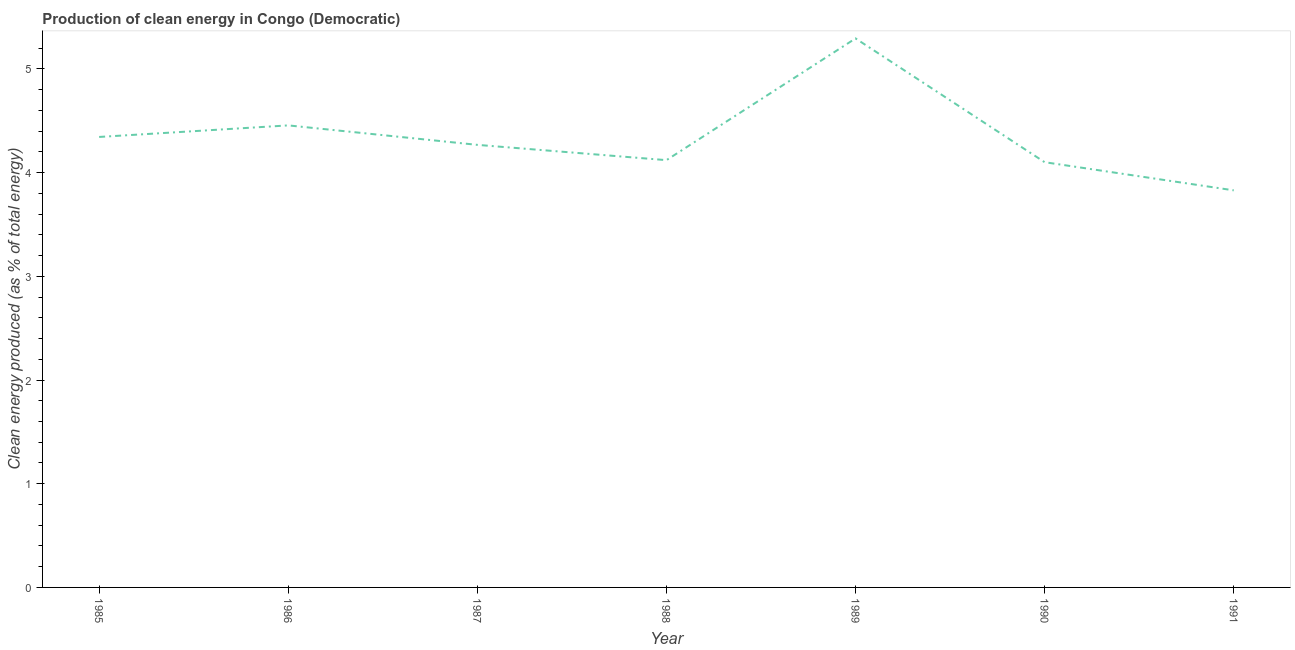What is the production of clean energy in 1986?
Your answer should be compact. 4.46. Across all years, what is the maximum production of clean energy?
Your response must be concise. 5.29. Across all years, what is the minimum production of clean energy?
Provide a succinct answer. 3.83. What is the sum of the production of clean energy?
Offer a very short reply. 30.41. What is the difference between the production of clean energy in 1985 and 1990?
Offer a terse response. 0.24. What is the average production of clean energy per year?
Your answer should be very brief. 4.34. What is the median production of clean energy?
Your response must be concise. 4.27. In how many years, is the production of clean energy greater than 1.4 %?
Offer a very short reply. 7. Do a majority of the years between 1989 and 1988 (inclusive) have production of clean energy greater than 3.2 %?
Give a very brief answer. No. What is the ratio of the production of clean energy in 1985 to that in 1988?
Keep it short and to the point. 1.05. Is the difference between the production of clean energy in 1987 and 1989 greater than the difference between any two years?
Give a very brief answer. No. What is the difference between the highest and the second highest production of clean energy?
Your answer should be very brief. 0.84. What is the difference between the highest and the lowest production of clean energy?
Your answer should be compact. 1.46. Does the production of clean energy monotonically increase over the years?
Give a very brief answer. No. How many years are there in the graph?
Ensure brevity in your answer.  7. Are the values on the major ticks of Y-axis written in scientific E-notation?
Your response must be concise. No. What is the title of the graph?
Ensure brevity in your answer.  Production of clean energy in Congo (Democratic). What is the label or title of the X-axis?
Ensure brevity in your answer.  Year. What is the label or title of the Y-axis?
Ensure brevity in your answer.  Clean energy produced (as % of total energy). What is the Clean energy produced (as % of total energy) of 1985?
Provide a succinct answer. 4.34. What is the Clean energy produced (as % of total energy) of 1986?
Offer a very short reply. 4.46. What is the Clean energy produced (as % of total energy) of 1987?
Ensure brevity in your answer.  4.27. What is the Clean energy produced (as % of total energy) of 1988?
Provide a succinct answer. 4.12. What is the Clean energy produced (as % of total energy) in 1989?
Offer a terse response. 5.29. What is the Clean energy produced (as % of total energy) in 1990?
Give a very brief answer. 4.1. What is the Clean energy produced (as % of total energy) of 1991?
Offer a terse response. 3.83. What is the difference between the Clean energy produced (as % of total energy) in 1985 and 1986?
Your answer should be compact. -0.11. What is the difference between the Clean energy produced (as % of total energy) in 1985 and 1987?
Give a very brief answer. 0.08. What is the difference between the Clean energy produced (as % of total energy) in 1985 and 1988?
Offer a very short reply. 0.22. What is the difference between the Clean energy produced (as % of total energy) in 1985 and 1989?
Provide a short and direct response. -0.95. What is the difference between the Clean energy produced (as % of total energy) in 1985 and 1990?
Make the answer very short. 0.24. What is the difference between the Clean energy produced (as % of total energy) in 1985 and 1991?
Your answer should be compact. 0.51. What is the difference between the Clean energy produced (as % of total energy) in 1986 and 1987?
Provide a short and direct response. 0.19. What is the difference between the Clean energy produced (as % of total energy) in 1986 and 1988?
Make the answer very short. 0.34. What is the difference between the Clean energy produced (as % of total energy) in 1986 and 1989?
Keep it short and to the point. -0.84. What is the difference between the Clean energy produced (as % of total energy) in 1986 and 1990?
Keep it short and to the point. 0.35. What is the difference between the Clean energy produced (as % of total energy) in 1986 and 1991?
Provide a short and direct response. 0.63. What is the difference between the Clean energy produced (as % of total energy) in 1987 and 1988?
Offer a terse response. 0.15. What is the difference between the Clean energy produced (as % of total energy) in 1987 and 1989?
Provide a succinct answer. -1.03. What is the difference between the Clean energy produced (as % of total energy) in 1987 and 1990?
Ensure brevity in your answer.  0.17. What is the difference between the Clean energy produced (as % of total energy) in 1987 and 1991?
Your answer should be very brief. 0.44. What is the difference between the Clean energy produced (as % of total energy) in 1988 and 1989?
Your answer should be very brief. -1.17. What is the difference between the Clean energy produced (as % of total energy) in 1988 and 1990?
Keep it short and to the point. 0.02. What is the difference between the Clean energy produced (as % of total energy) in 1988 and 1991?
Provide a short and direct response. 0.29. What is the difference between the Clean energy produced (as % of total energy) in 1989 and 1990?
Offer a very short reply. 1.19. What is the difference between the Clean energy produced (as % of total energy) in 1989 and 1991?
Provide a short and direct response. 1.46. What is the difference between the Clean energy produced (as % of total energy) in 1990 and 1991?
Ensure brevity in your answer.  0.27. What is the ratio of the Clean energy produced (as % of total energy) in 1985 to that in 1986?
Provide a succinct answer. 0.97. What is the ratio of the Clean energy produced (as % of total energy) in 1985 to that in 1987?
Provide a succinct answer. 1.02. What is the ratio of the Clean energy produced (as % of total energy) in 1985 to that in 1988?
Give a very brief answer. 1.05. What is the ratio of the Clean energy produced (as % of total energy) in 1985 to that in 1989?
Give a very brief answer. 0.82. What is the ratio of the Clean energy produced (as % of total energy) in 1985 to that in 1990?
Make the answer very short. 1.06. What is the ratio of the Clean energy produced (as % of total energy) in 1985 to that in 1991?
Keep it short and to the point. 1.13. What is the ratio of the Clean energy produced (as % of total energy) in 1986 to that in 1987?
Ensure brevity in your answer.  1.04. What is the ratio of the Clean energy produced (as % of total energy) in 1986 to that in 1988?
Make the answer very short. 1.08. What is the ratio of the Clean energy produced (as % of total energy) in 1986 to that in 1989?
Make the answer very short. 0.84. What is the ratio of the Clean energy produced (as % of total energy) in 1986 to that in 1990?
Make the answer very short. 1.09. What is the ratio of the Clean energy produced (as % of total energy) in 1986 to that in 1991?
Provide a short and direct response. 1.16. What is the ratio of the Clean energy produced (as % of total energy) in 1987 to that in 1988?
Provide a succinct answer. 1.04. What is the ratio of the Clean energy produced (as % of total energy) in 1987 to that in 1989?
Your response must be concise. 0.81. What is the ratio of the Clean energy produced (as % of total energy) in 1987 to that in 1990?
Offer a very short reply. 1.04. What is the ratio of the Clean energy produced (as % of total energy) in 1987 to that in 1991?
Provide a succinct answer. 1.11. What is the ratio of the Clean energy produced (as % of total energy) in 1988 to that in 1989?
Ensure brevity in your answer.  0.78. What is the ratio of the Clean energy produced (as % of total energy) in 1988 to that in 1991?
Provide a succinct answer. 1.08. What is the ratio of the Clean energy produced (as % of total energy) in 1989 to that in 1990?
Your response must be concise. 1.29. What is the ratio of the Clean energy produced (as % of total energy) in 1989 to that in 1991?
Make the answer very short. 1.38. What is the ratio of the Clean energy produced (as % of total energy) in 1990 to that in 1991?
Ensure brevity in your answer.  1.07. 